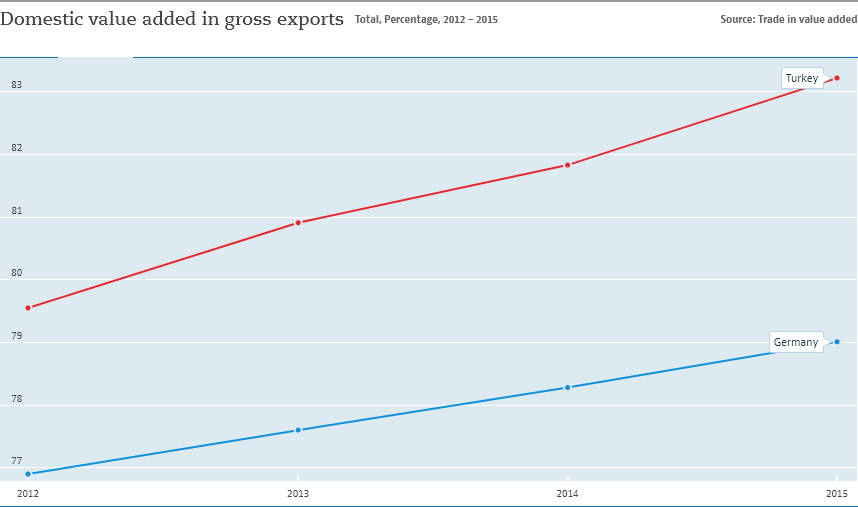Draw attention to some important aspects in this diagram. In 2012, the amount of value added to goods and services produced in Germany for export, as compared to the total value of those exports, was the lowest on record. The domestic value added in gross exports in Germany has consistently increased over the years, as confirmed by the data. 